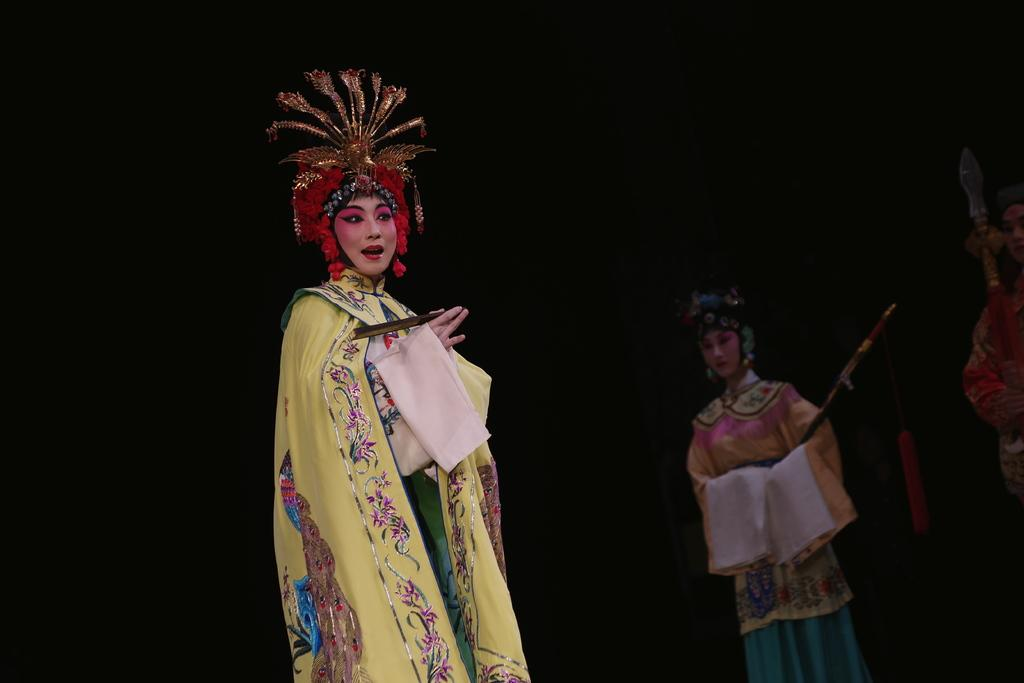Who or what can be seen in the image? There are people in the image. What are the people wearing? The people are wearing costumes. Where are the people performing? The people are performing on a stage. Who or what are the people looking at? The people are looking at someone. What type of protest is happening in the image? There is no protest present in the image; it features people wearing costumes and performing on a stage. Can you see a bomb in the image? There is no bomb present in the image. 